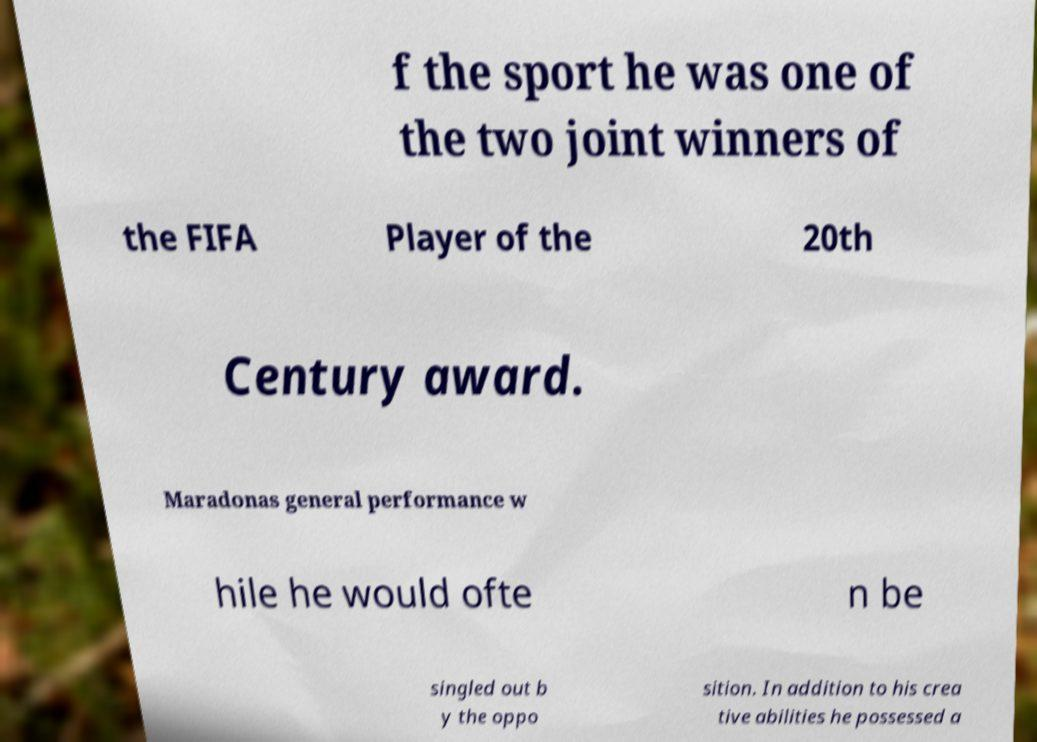For documentation purposes, I need the text within this image transcribed. Could you provide that? f the sport he was one of the two joint winners of the FIFA Player of the 20th Century award. Maradonas general performance w hile he would ofte n be singled out b y the oppo sition. In addition to his crea tive abilities he possessed a 